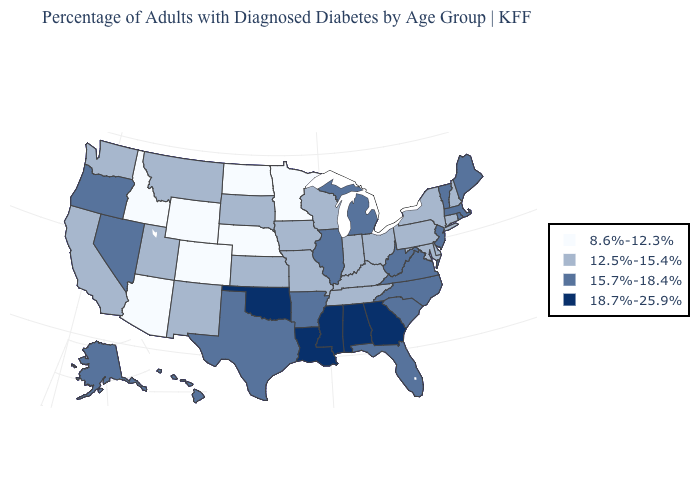What is the value of Delaware?
Short answer required. 12.5%-15.4%. Name the states that have a value in the range 12.5%-15.4%?
Concise answer only. California, Connecticut, Delaware, Indiana, Iowa, Kansas, Kentucky, Maryland, Missouri, Montana, New Hampshire, New Mexico, New York, Ohio, Pennsylvania, South Dakota, Tennessee, Utah, Washington, Wisconsin. Which states hav the highest value in the South?
Be succinct. Alabama, Georgia, Louisiana, Mississippi, Oklahoma. Does Nevada have the lowest value in the USA?
Give a very brief answer. No. Does Kansas have the same value as Colorado?
Be succinct. No. Which states hav the highest value in the MidWest?
Short answer required. Illinois, Michigan. Which states have the lowest value in the USA?
Write a very short answer. Arizona, Colorado, Idaho, Minnesota, Nebraska, North Dakota, Wyoming. Name the states that have a value in the range 8.6%-12.3%?
Be succinct. Arizona, Colorado, Idaho, Minnesota, Nebraska, North Dakota, Wyoming. Does Oklahoma have the highest value in the USA?
Give a very brief answer. Yes. Name the states that have a value in the range 18.7%-25.9%?
Quick response, please. Alabama, Georgia, Louisiana, Mississippi, Oklahoma. What is the highest value in the USA?
Keep it brief. 18.7%-25.9%. Name the states that have a value in the range 18.7%-25.9%?
Concise answer only. Alabama, Georgia, Louisiana, Mississippi, Oklahoma. Name the states that have a value in the range 18.7%-25.9%?
Keep it brief. Alabama, Georgia, Louisiana, Mississippi, Oklahoma. Which states hav the highest value in the South?
Write a very short answer. Alabama, Georgia, Louisiana, Mississippi, Oklahoma. Name the states that have a value in the range 12.5%-15.4%?
Concise answer only. California, Connecticut, Delaware, Indiana, Iowa, Kansas, Kentucky, Maryland, Missouri, Montana, New Hampshire, New Mexico, New York, Ohio, Pennsylvania, South Dakota, Tennessee, Utah, Washington, Wisconsin. 